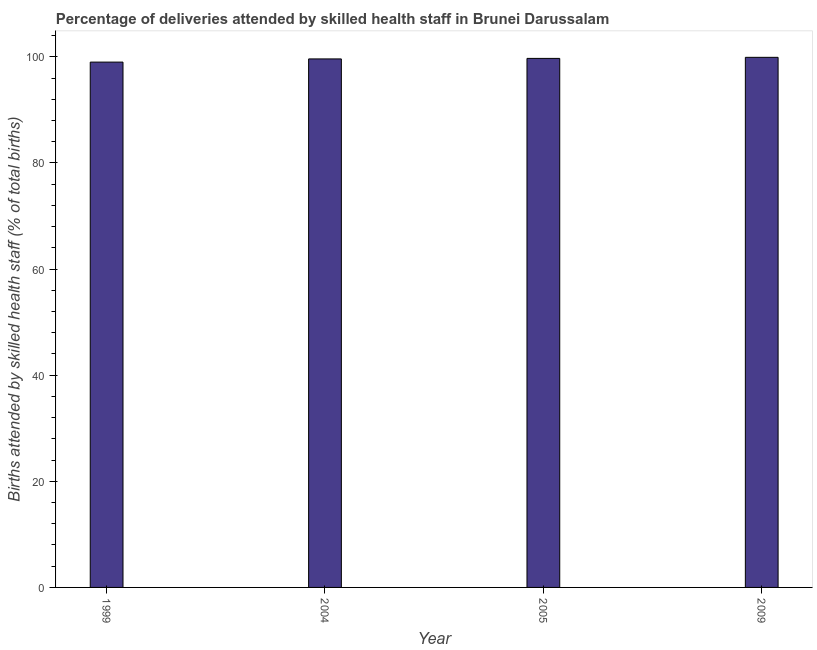Does the graph contain grids?
Your answer should be compact. No. What is the title of the graph?
Offer a terse response. Percentage of deliveries attended by skilled health staff in Brunei Darussalam. What is the label or title of the Y-axis?
Your answer should be compact. Births attended by skilled health staff (% of total births). What is the number of births attended by skilled health staff in 2009?
Your response must be concise. 99.9. Across all years, what is the maximum number of births attended by skilled health staff?
Offer a terse response. 99.9. In which year was the number of births attended by skilled health staff minimum?
Provide a short and direct response. 1999. What is the sum of the number of births attended by skilled health staff?
Your answer should be very brief. 398.2. What is the difference between the number of births attended by skilled health staff in 1999 and 2009?
Make the answer very short. -0.9. What is the average number of births attended by skilled health staff per year?
Your answer should be very brief. 99.55. What is the median number of births attended by skilled health staff?
Make the answer very short. 99.65. Is the difference between the number of births attended by skilled health staff in 2005 and 2009 greater than the difference between any two years?
Give a very brief answer. No. In how many years, is the number of births attended by skilled health staff greater than the average number of births attended by skilled health staff taken over all years?
Give a very brief answer. 3. How many bars are there?
Offer a terse response. 4. What is the difference between two consecutive major ticks on the Y-axis?
Give a very brief answer. 20. Are the values on the major ticks of Y-axis written in scientific E-notation?
Give a very brief answer. No. What is the Births attended by skilled health staff (% of total births) of 2004?
Keep it short and to the point. 99.6. What is the Births attended by skilled health staff (% of total births) of 2005?
Ensure brevity in your answer.  99.7. What is the Births attended by skilled health staff (% of total births) in 2009?
Your answer should be compact. 99.9. What is the difference between the Births attended by skilled health staff (% of total births) in 1999 and 2005?
Offer a very short reply. -0.7. What is the difference between the Births attended by skilled health staff (% of total births) in 2004 and 2005?
Offer a very short reply. -0.1. What is the ratio of the Births attended by skilled health staff (% of total births) in 2004 to that in 2005?
Ensure brevity in your answer.  1. What is the ratio of the Births attended by skilled health staff (% of total births) in 2004 to that in 2009?
Your answer should be very brief. 1. 